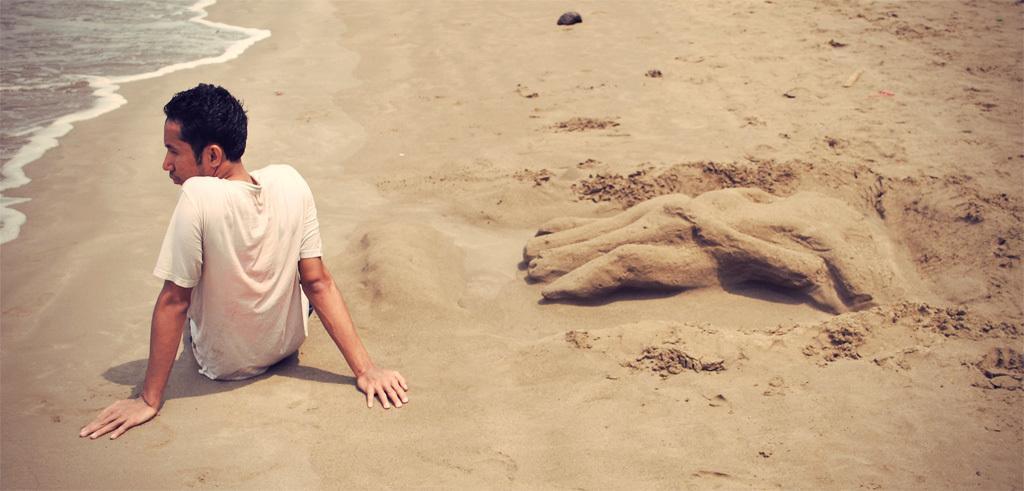Can you describe this image briefly? In this image we can see a person sitting on the sand, there is a sand art, also we can see the water. 